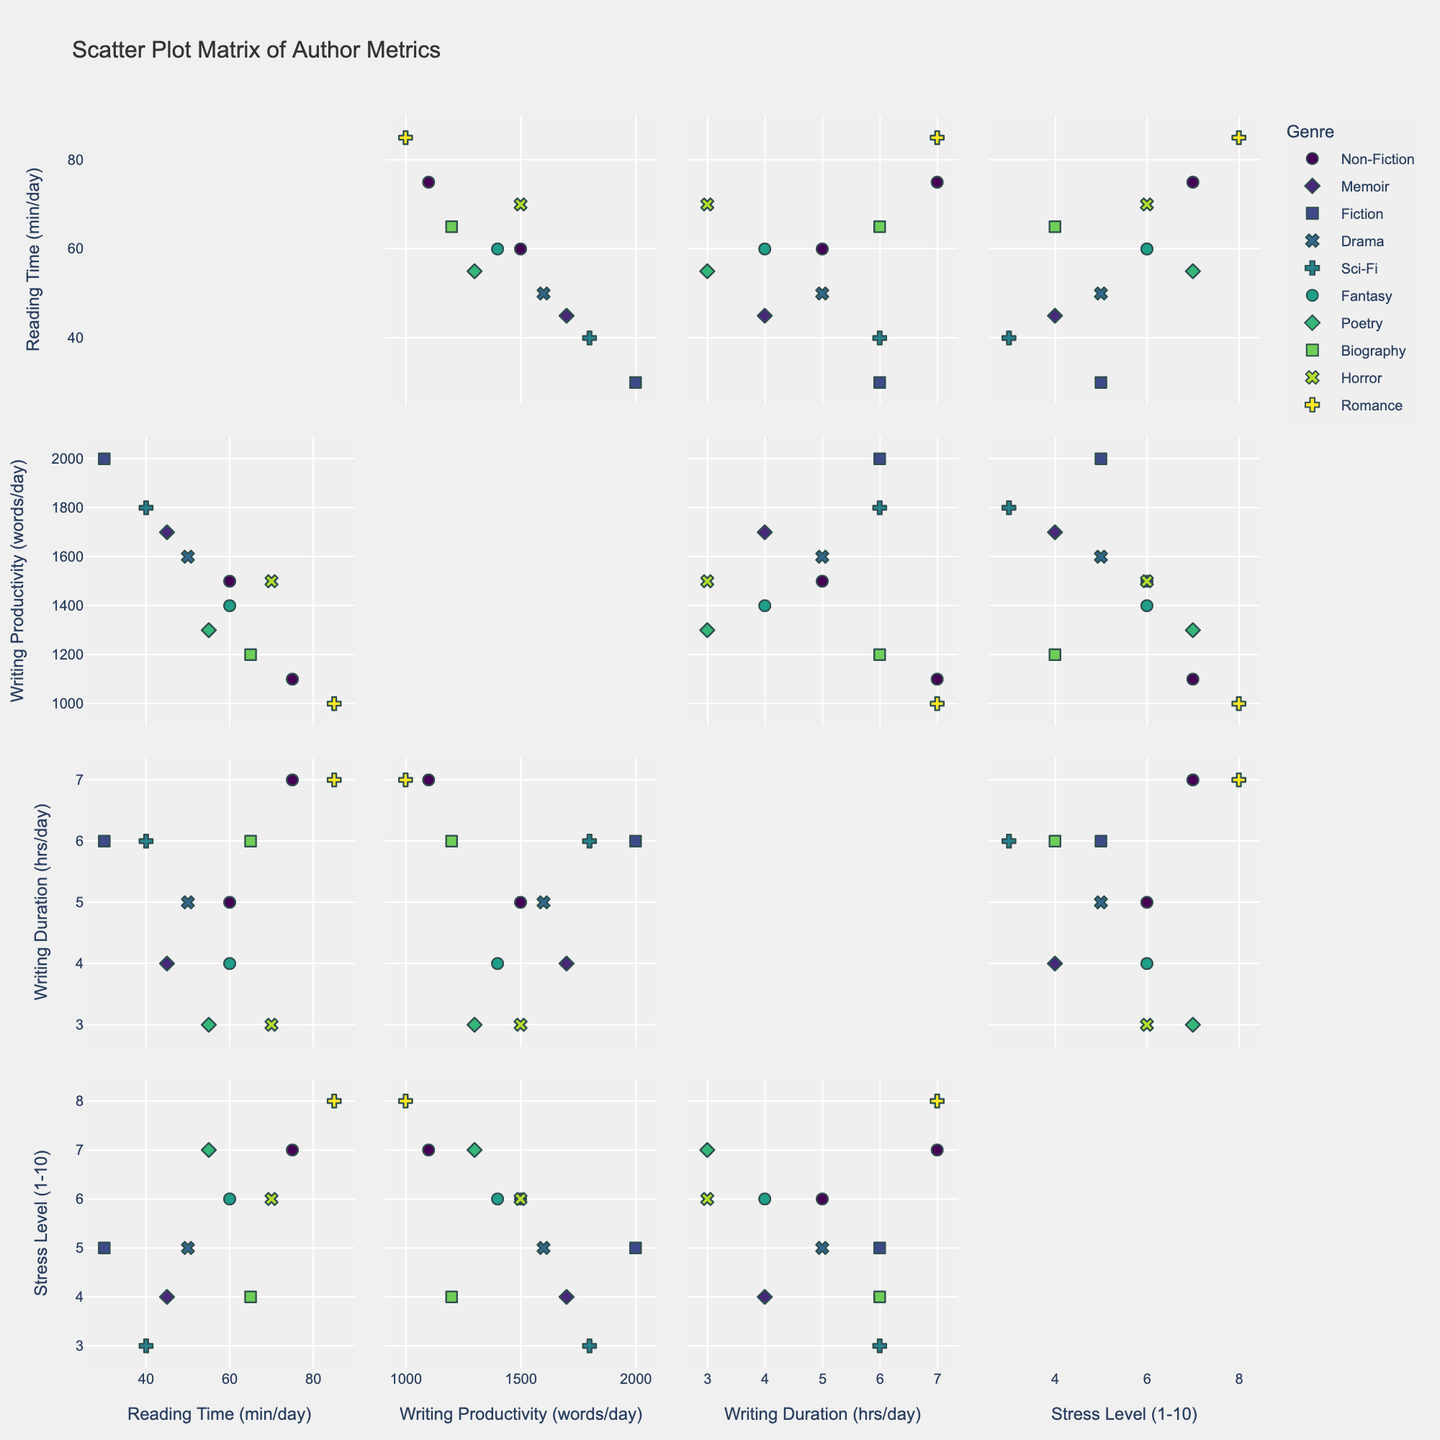What's the title of the figure? The title is typically found at the top center of the figure. In this SPLOM, the title clearly reads "Scatter Plot Matrix of Author Metrics".
Answer: Scatter Plot Matrix of Author Metrics How many dimensions are represented in the Scatter Plot Matrix (SPLOM)? Count the number of distinct axes or labels along the diagonal, indicating different variables. Here, there are four: 'Reading Time (min/day)', 'Writing Productivity (words/day)', 'Writing Duration (hrs/day)', and 'Stress Level (1-10)'.
Answer: Four Which genre has an author with the highest stress level and what is that level? Find the data point in the SPLOM where 'Stress Level (1 to 10)' is at its maximum. Then, check the corresponding 'Genre' for that data point. The highest stress level is for 'Romance' with a level of 8 (Barbara Walker).
Answer: Romance, 8 Does there appear to be any trend between Reading Time and Writing Productivity? Look at the scatter plots comparing 'Reading Time (min/day)' with 'Writing Productivity (words/day)'. Observe if the points show any increasing or decreasing trend. Authors with higher reading times generally do not have proportionally higher writing productivity.
Answer: No clear trend Which author spends the most time writing per day and how many hours do they write? Check the 'Writing Duration (hrs/day)' axis in the SPLOM and find the maximum value. Then identify the author corresponding to that value. James Williams and Barbara Walker both write for 7 hours a day.
Answer: James Williams, Barbara Walker, 7 hours Is there any visible correlation between Stress Level and Writing Productivity? Examine the scatter plot of 'Stress Level (1 to 10)' versus 'Writing Productivity (words/day)'. Look for any obvious trends or patterns in the data points. There appears to be no strong correlation between stress level and writing productivity.
Answer: No strong correlation Which author has the least reading time per day and how many minutes do they read? Find the minimum value of 'Reading Time (min/day)' from the SPLOM. Then determine the author associated with this minimum value. Jessica Brown reads the least with 30 minutes per day.
Answer: Jessica Brown, 30 minutes How does the genre 'Fiction' compare to 'Non-Fiction' in terms of Writing Productivity? Look at the scatter plots where 'Writing Productivity (words/day)' is plotted against other factors and observe the points labeled as 'Fiction' and 'Non-Fiction'. Fiction authors generally have higher writing productivity, e.g., Jessica Brown with 2000 words/day, compared to Non-Fiction e.g., Sarah Johnson with 1500 words/day.
Answer: Fiction higher than Non-Fiction; 2000 vs 1500 words/day What is the average Writing Duration for all the authors combined? Sum all the values of 'Writing Duration (hrs/day)' and divide by the number of authors. The total is (5+4+6+7+5+6+4+3+6+3+7) = 56 hours, so the average is 56/11.
Answer: 5.09 hours per day 